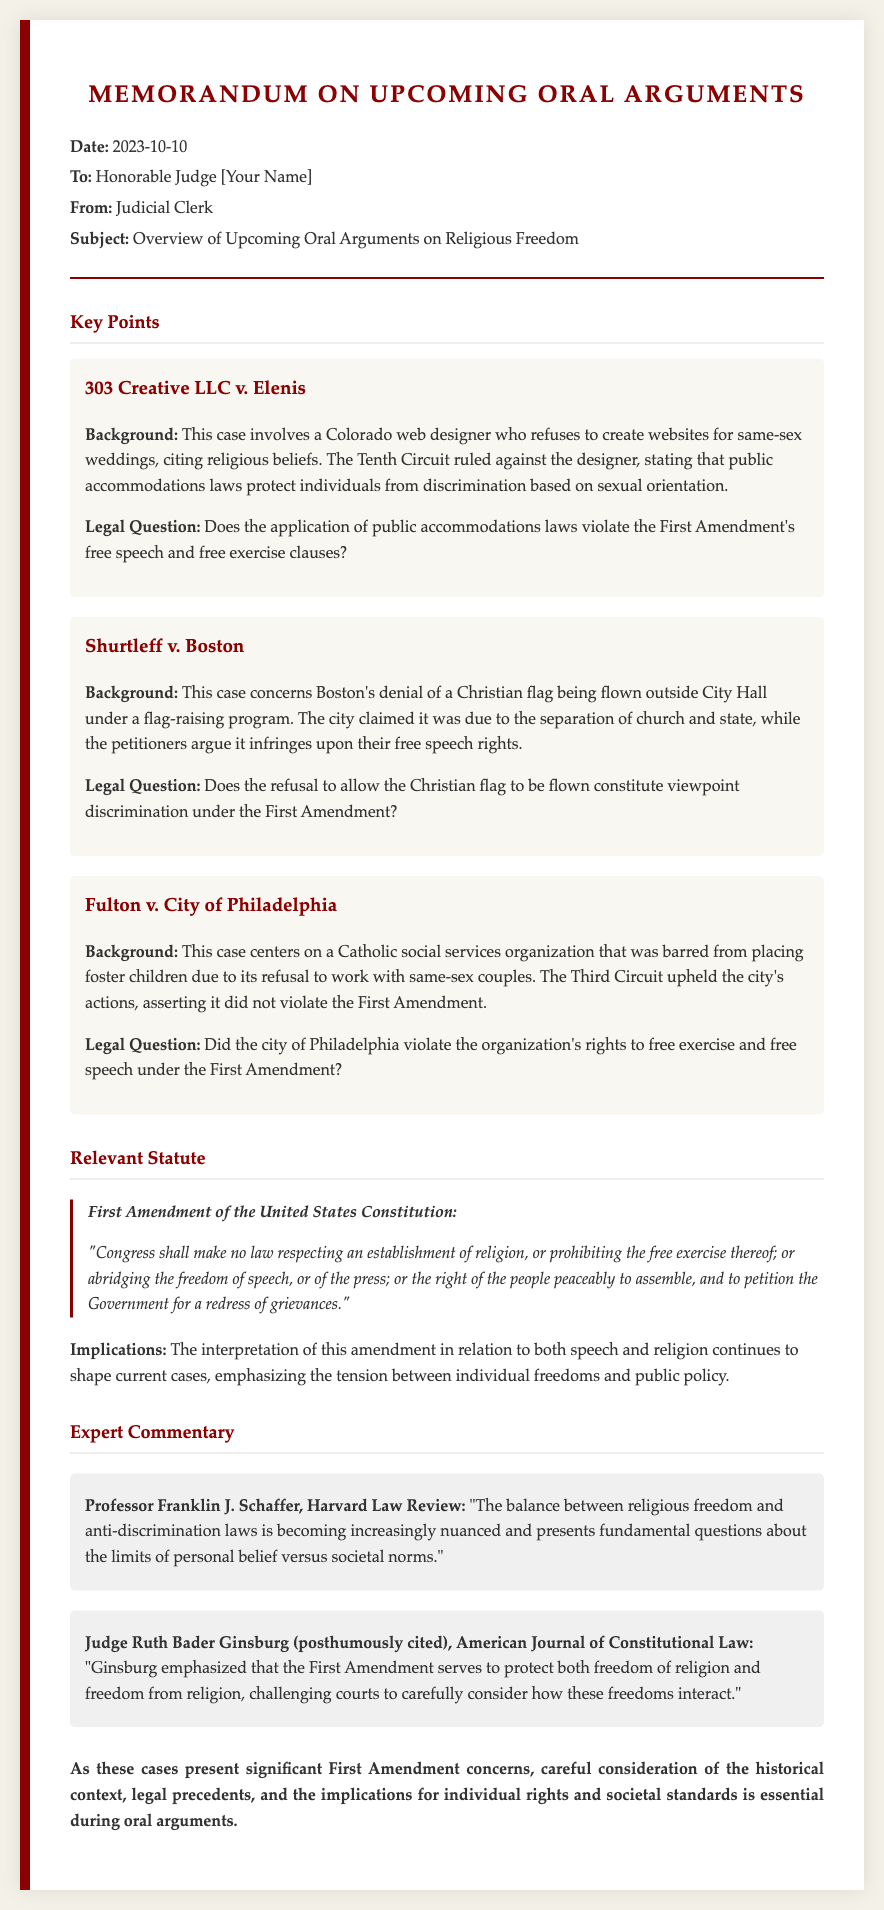What is the date of the memorandum? The date of the memorandum is explicitly stated in the header section, which shows "2023-10-10."
Answer: 2023-10-10 Who authored the memorandum? The author of the memorandum is mentioned in the header section as "Judicial Clerk."
Answer: Judicial Clerk What is the subject of the memorandum? The subject is outlined clearly in the header and is "Overview of Upcoming Oral Arguments on Religious Freedom."
Answer: Overview of Upcoming Oral Arguments on Religious Freedom What case involves a web designer refusing to create websites for same-sex weddings? The case pertaining to a web designer is identified as "303 Creative LLC v. Elenis."
Answer: 303 Creative LLC v. Elenis Which legal question is posed in Fulton v. City of Philadelphia? The legal question for this case is provided as part of the background and specifically addresses the city's actions regarding free exercise and free speech.
Answer: Did the city of Philadelphia violate the organization's rights to free exercise and free speech under the First Amendment? What key legal principle is discussed in the expert commentary? The expert commentary discusses the balance between "religious freedom and anti-discrimination laws."
Answer: religious freedom and anti-discrimination laws What does the First Amendment state regarding religion? The First Amendment text is quoted in the document, specifically addressing Congress's role in relation to religion and freedom of speech.
Answer: "Congress shall make no law respecting an establishment of religion, or prohibiting the free exercise thereof..." What recent insight did Judge Ruth Bader Ginsburg offer? The commentary cites a posthumous insight about the First Amendment protecting both "freedom of religion and freedom from religion."
Answer: freedom of religion and freedom from religion What type of cases are being discussed in the memorandum? The types of cases mentioned throughout the document center around "religious freedom."
Answer: religious freedom 